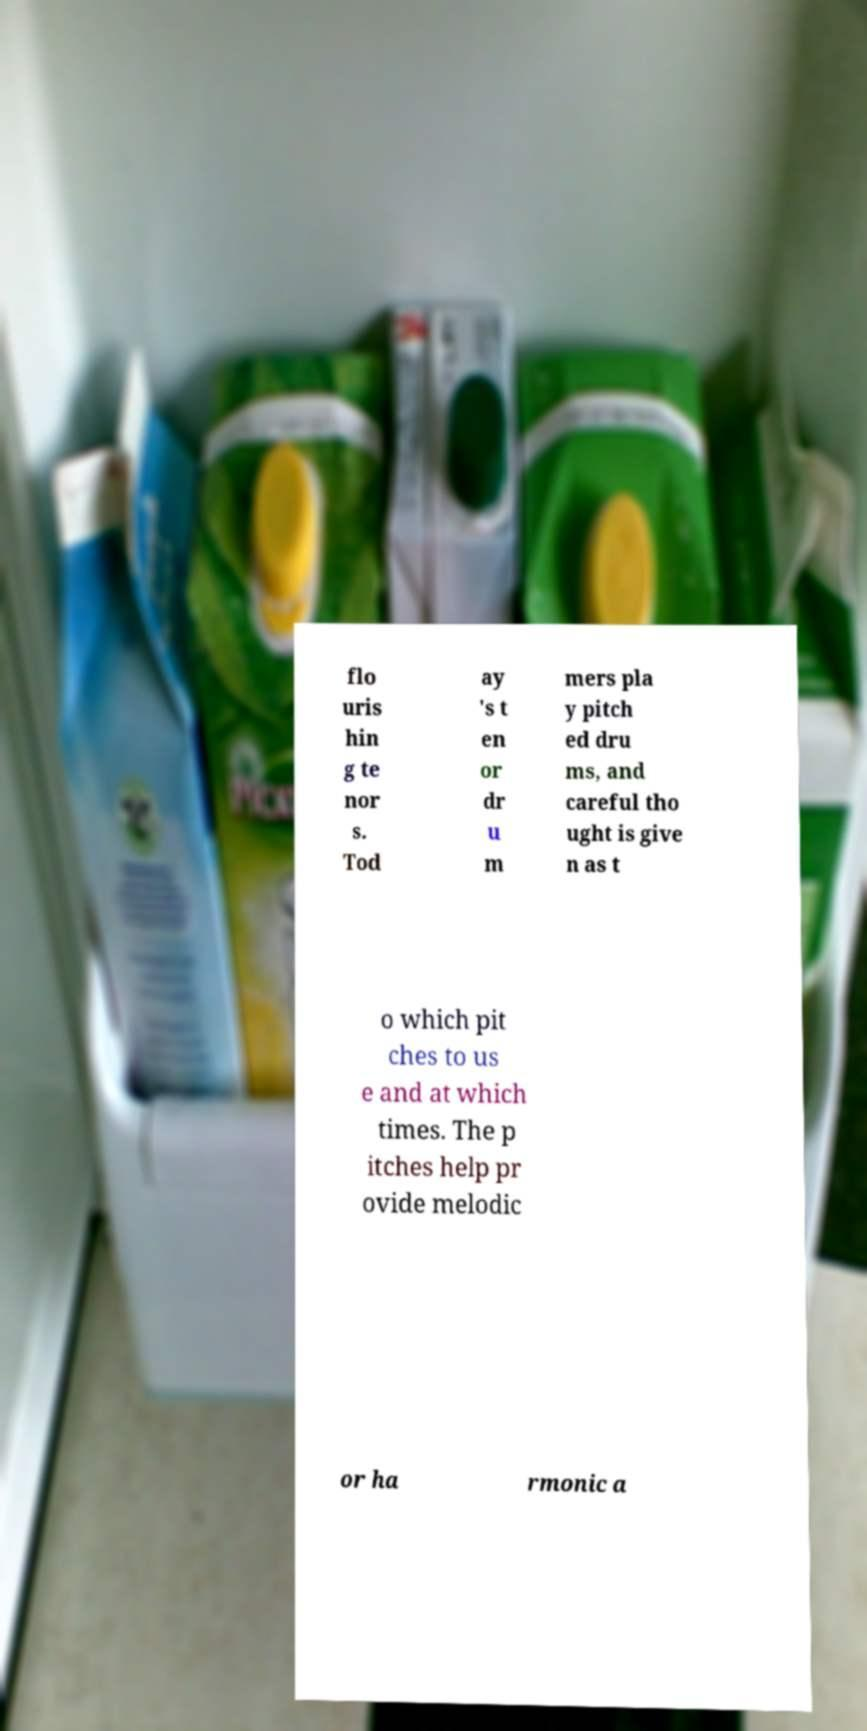I need the written content from this picture converted into text. Can you do that? flo uris hin g te nor s. Tod ay 's t en or dr u m mers pla y pitch ed dru ms, and careful tho ught is give n as t o which pit ches to us e and at which times. The p itches help pr ovide melodic or ha rmonic a 